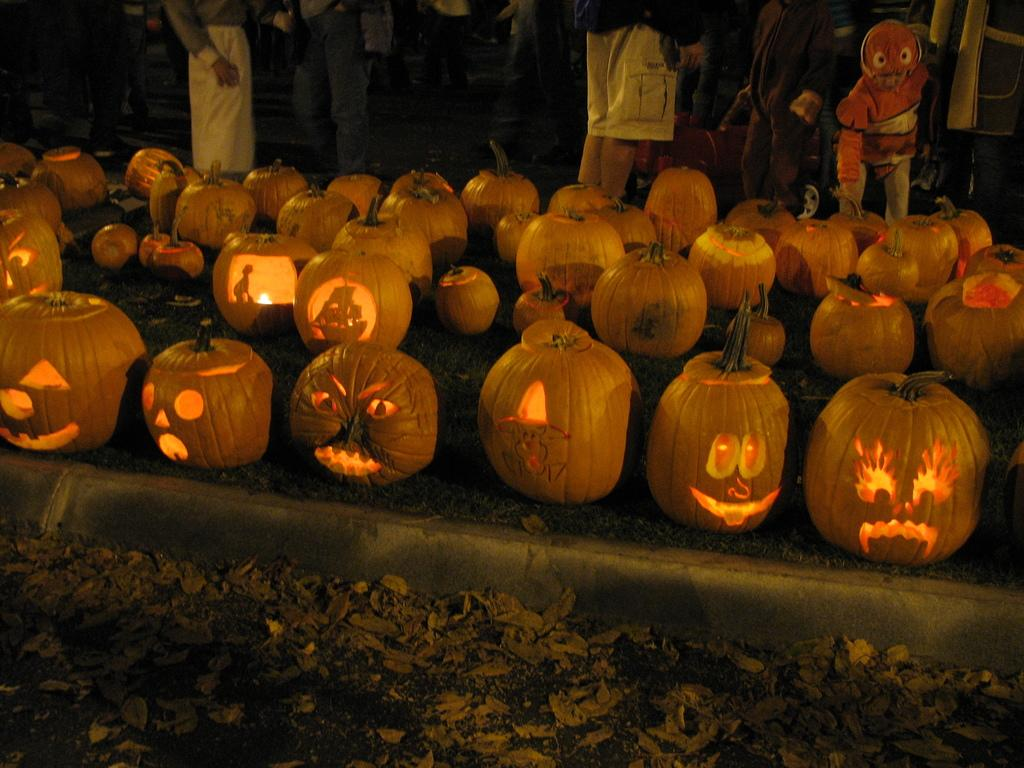What can be seen in the foreground of the image? In the foreground of the image, there are dry leaves and pumpkins with light inside them. What might the pumpkins with light inside them be used for? The pumpkins with light inside them might be used for decoration or as part of a festive display. Where are the people located in the image? The people are standing at the top of the image. What type of fish can be seen swimming in the image? There are no fish present in the image; it features dry leaves, pumpkins with light inside them, and people standing at the top. How many bears are visible in the image? There are no bears present in the image. 